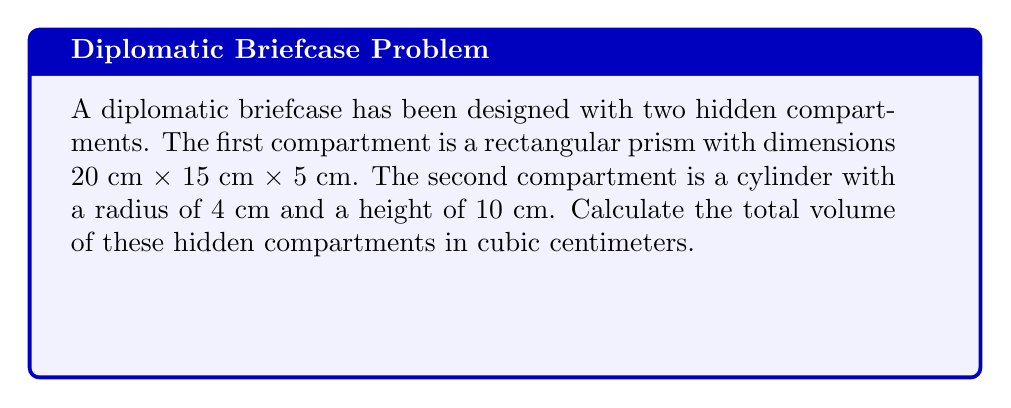Teach me how to tackle this problem. To solve this problem, we need to calculate the volumes of both compartments separately and then add them together.

1. Volume of the rectangular prism:
   $$V_1 = l \times w \times h$$
   $$V_1 = 20 \text{ cm} \times 15 \text{ cm} \times 5 \text{ cm} = 1500 \text{ cm}^3$$

2. Volume of the cylinder:
   $$V_2 = \pi r^2 h$$
   $$V_2 = \pi \times (4 \text{ cm})^2 \times 10 \text{ cm} = 160\pi \text{ cm}^3$$

3. Total volume:
   $$V_{\text{total}} = V_1 + V_2$$
   $$V_{\text{total}} = 1500 \text{ cm}^3 + 160\pi \text{ cm}^3$$
   $$V_{\text{total}} = 1500 + 502.65 \text{ cm}^3 \approx 2002.65 \text{ cm}^3$$

Therefore, the total volume of the hidden compartments is approximately 2002.65 cubic centimeters.
Answer: 2002.65 cm³ 